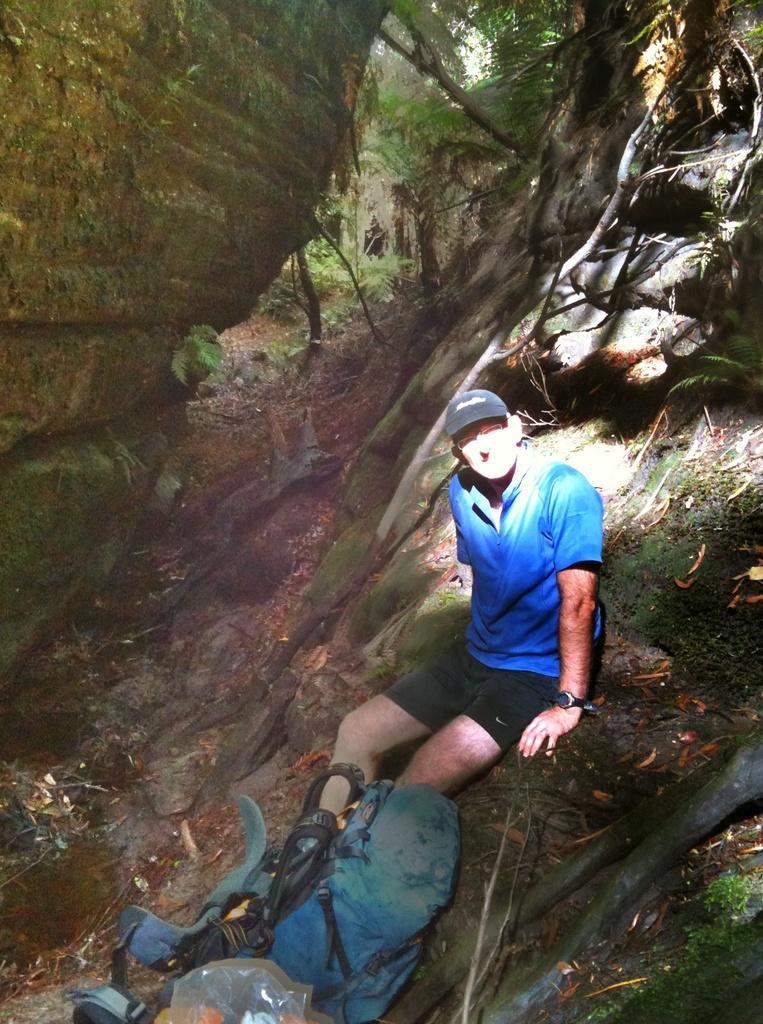Can you describe this image briefly? In this image there is a person sitting on the surface and there are a few objects, behind him there are like mountains and trees. 